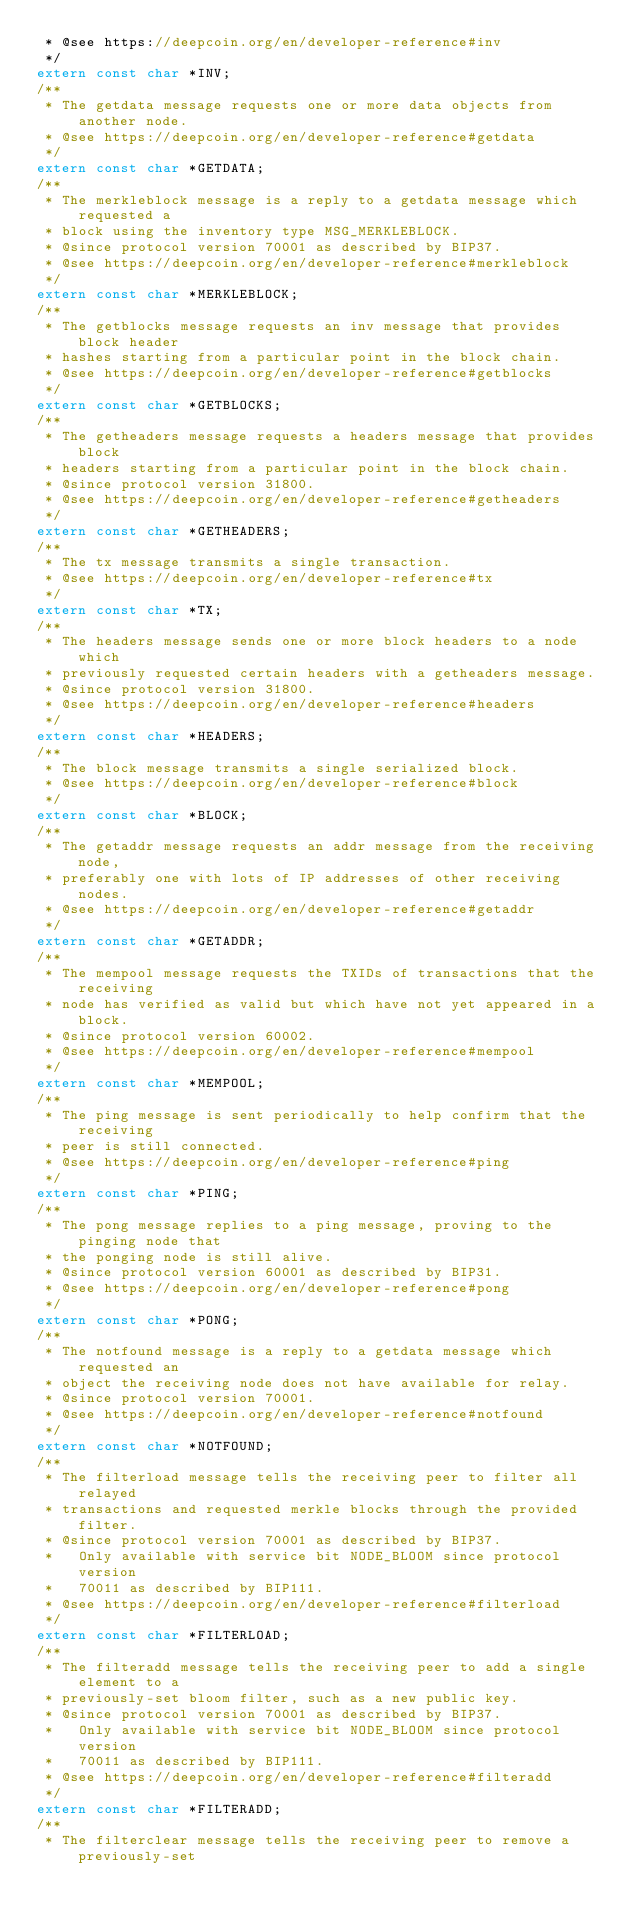Convert code to text. <code><loc_0><loc_0><loc_500><loc_500><_C_> * @see https://deepcoin.org/en/developer-reference#inv
 */
extern const char *INV;
/**
 * The getdata message requests one or more data objects from another node.
 * @see https://deepcoin.org/en/developer-reference#getdata
 */
extern const char *GETDATA;
/**
 * The merkleblock message is a reply to a getdata message which requested a
 * block using the inventory type MSG_MERKLEBLOCK.
 * @since protocol version 70001 as described by BIP37.
 * @see https://deepcoin.org/en/developer-reference#merkleblock
 */
extern const char *MERKLEBLOCK;
/**
 * The getblocks message requests an inv message that provides block header
 * hashes starting from a particular point in the block chain.
 * @see https://deepcoin.org/en/developer-reference#getblocks
 */
extern const char *GETBLOCKS;
/**
 * The getheaders message requests a headers message that provides block
 * headers starting from a particular point in the block chain.
 * @since protocol version 31800.
 * @see https://deepcoin.org/en/developer-reference#getheaders
 */
extern const char *GETHEADERS;
/**
 * The tx message transmits a single transaction.
 * @see https://deepcoin.org/en/developer-reference#tx
 */
extern const char *TX;
/**
 * The headers message sends one or more block headers to a node which
 * previously requested certain headers with a getheaders message.
 * @since protocol version 31800.
 * @see https://deepcoin.org/en/developer-reference#headers
 */
extern const char *HEADERS;
/**
 * The block message transmits a single serialized block.
 * @see https://deepcoin.org/en/developer-reference#block
 */
extern const char *BLOCK;
/**
 * The getaddr message requests an addr message from the receiving node,
 * preferably one with lots of IP addresses of other receiving nodes.
 * @see https://deepcoin.org/en/developer-reference#getaddr
 */
extern const char *GETADDR;
/**
 * The mempool message requests the TXIDs of transactions that the receiving
 * node has verified as valid but which have not yet appeared in a block.
 * @since protocol version 60002.
 * @see https://deepcoin.org/en/developer-reference#mempool
 */
extern const char *MEMPOOL;
/**
 * The ping message is sent periodically to help confirm that the receiving
 * peer is still connected.
 * @see https://deepcoin.org/en/developer-reference#ping
 */
extern const char *PING;
/**
 * The pong message replies to a ping message, proving to the pinging node that
 * the ponging node is still alive.
 * @since protocol version 60001 as described by BIP31.
 * @see https://deepcoin.org/en/developer-reference#pong
 */
extern const char *PONG;
/**
 * The notfound message is a reply to a getdata message which requested an
 * object the receiving node does not have available for relay.
 * @since protocol version 70001.
 * @see https://deepcoin.org/en/developer-reference#notfound
 */
extern const char *NOTFOUND;
/**
 * The filterload message tells the receiving peer to filter all relayed
 * transactions and requested merkle blocks through the provided filter.
 * @since protocol version 70001 as described by BIP37.
 *   Only available with service bit NODE_BLOOM since protocol version
 *   70011 as described by BIP111.
 * @see https://deepcoin.org/en/developer-reference#filterload
 */
extern const char *FILTERLOAD;
/**
 * The filteradd message tells the receiving peer to add a single element to a
 * previously-set bloom filter, such as a new public key.
 * @since protocol version 70001 as described by BIP37.
 *   Only available with service bit NODE_BLOOM since protocol version
 *   70011 as described by BIP111.
 * @see https://deepcoin.org/en/developer-reference#filteradd
 */
extern const char *FILTERADD;
/**
 * The filterclear message tells the receiving peer to remove a previously-set</code> 